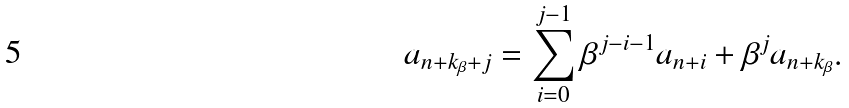<formula> <loc_0><loc_0><loc_500><loc_500>a _ { n + k _ { \beta } + j } = \sum _ { i = 0 } ^ { j - 1 } \beta ^ { j - i - 1 } a _ { n + i } + \beta ^ { j } a _ { n + k _ { \beta } } .</formula> 